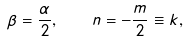<formula> <loc_0><loc_0><loc_500><loc_500>\beta = \frac { \alpha } { 2 } , \quad \, n = - \frac { m } { 2 } \equiv k ,</formula> 